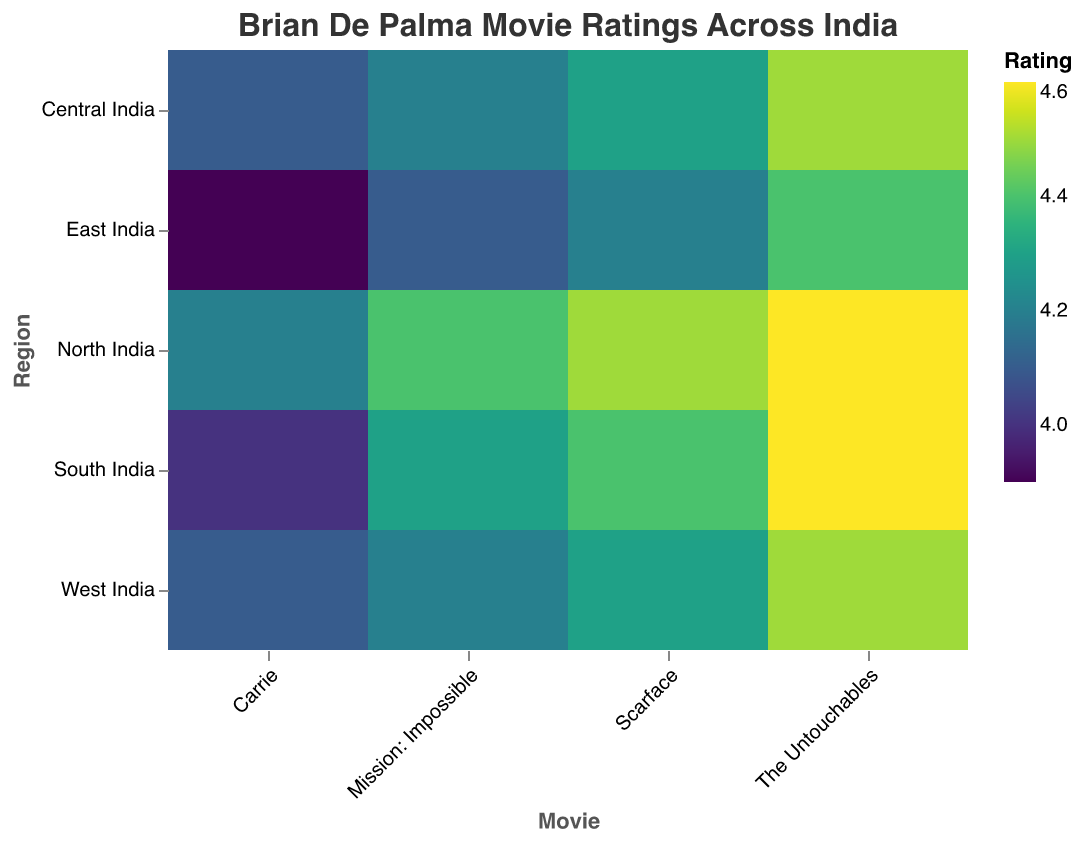What's the title of the heatmap? The title is displayed at the top of the heatmap. It reads "Brian De Palma Movie Ratings Across India".
Answer: Brian De Palma Movie Ratings Across India Which movie received the highest rating in North India? In North India, the highest rating can be found by comparing all the ratings. "The Untouchables" has a rating of 4.6, which is the highest.
Answer: The Untouchables How does the rating of "Carrie" compare between North India and East India? In North India, "Carrie" has a rating of 4.2, whereas in East India, it has a rating of 3.9. 4.2 is higher than 3.9.
Answer: North India has a higher rating for "Carrie" What's the average rating of "Scarface" across all regions? To find the average, sum the ratings of "Scarface" in all regions and divide by the number of regions: (4.5 + 4.3 + 4.4 + 4.2 + 4.3) / 5 = 21.7 / 5.
Answer: 4.34 Which region shows the lowest rating for "The Untouchables"? By comparing the ratings of "The Untouchables" across all regions (4.6, 4.5, 4.6, 4.4, 4.5), we can see that East India has the lowest rating of 4.4.
Answer: East India How many regions rated "Mission: Impossible" higher than 4.2? By looking at the ratings for "Mission: Impossible" (4.4, 4.2, 4.3, 4.1, 4.2), North India, South India, and Central India rated it higher than 4.2. That's 3 regions.
Answer: 3 regions What's the color scheme used for rating representation in the heatmap? The heatmap uses the "viridis" color scheme, ranging from a lower bound of 3.9 to an upper bound of 4.6.
Answer: viridis What is the range of ratings represented in the heatmap? The ratings range from the lowest rating, 3.9, to the highest rating, 4.6, as per the color legend.
Answer: 3.9 to 4.6 Among "Carrie", "Scarface", and "Mission: Impossible", which movie has the widest range of ratings across different regions? To find the range for each:
   - "Carrie": Highest (4.2 in North India) - Lowest (3.9 in East India) = 0.3
   - "Scarface": Highest (4.5 in North India) - Lowest (4.2 in East India) = 0.3
   - "Mission: Impossible": Highest (4.4 in North India) - Lowest (4.1 in East India) = 0.3
   All have the same range of ratings, 0.3.
Answer: All movies have the same range Is there any movie that has the same rating across all regions? By checking the ratings of each movie across all regions, none of the movies have identical ratings in every region.
Answer: No 